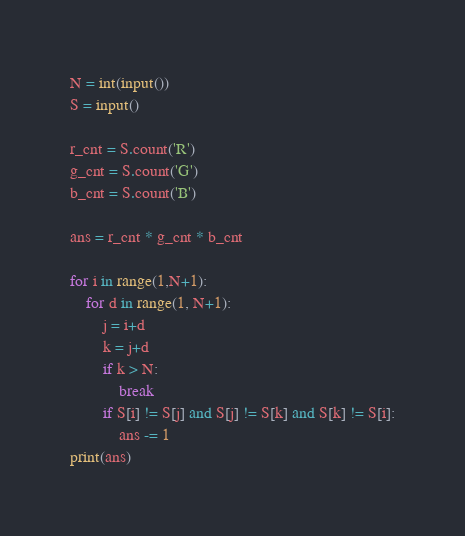<code> <loc_0><loc_0><loc_500><loc_500><_Python_>N = int(input())
S = input()

r_cnt = S.count('R')
g_cnt = S.count('G')
b_cnt = S.count('B')

ans = r_cnt * g_cnt * b_cnt

for i in range(1,N+1):
    for d in range(1, N+1):
        j = i+d
        k = j+d
        if k > N:
            break
        if S[i] != S[j] and S[j] != S[k] and S[k] != S[i]:
            ans -= 1
print(ans)</code> 